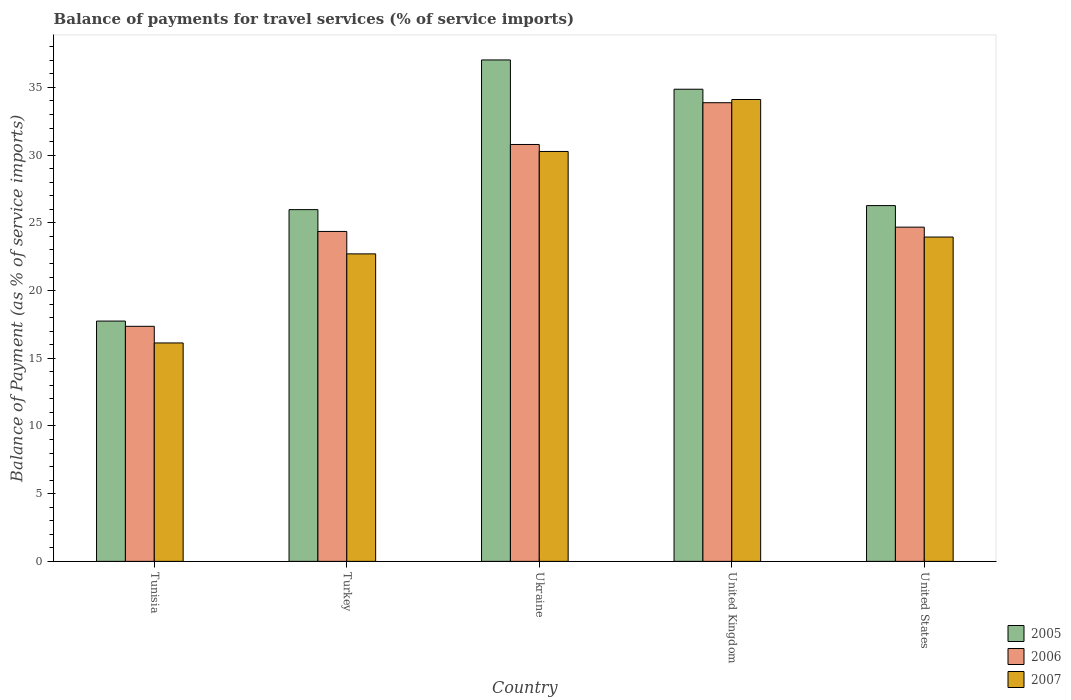How many different coloured bars are there?
Offer a terse response. 3. How many groups of bars are there?
Offer a very short reply. 5. How many bars are there on the 5th tick from the left?
Provide a short and direct response. 3. What is the balance of payments for travel services in 2006 in United States?
Give a very brief answer. 24.68. Across all countries, what is the maximum balance of payments for travel services in 2007?
Your response must be concise. 34.11. Across all countries, what is the minimum balance of payments for travel services in 2006?
Offer a very short reply. 17.36. In which country was the balance of payments for travel services in 2005 maximum?
Your answer should be very brief. Ukraine. In which country was the balance of payments for travel services in 2007 minimum?
Offer a terse response. Tunisia. What is the total balance of payments for travel services in 2005 in the graph?
Your response must be concise. 141.89. What is the difference between the balance of payments for travel services in 2007 in Turkey and that in United Kingdom?
Provide a succinct answer. -11.4. What is the difference between the balance of payments for travel services in 2007 in Ukraine and the balance of payments for travel services in 2005 in United Kingdom?
Offer a terse response. -4.6. What is the average balance of payments for travel services in 2005 per country?
Provide a short and direct response. 28.38. What is the difference between the balance of payments for travel services of/in 2007 and balance of payments for travel services of/in 2005 in United Kingdom?
Ensure brevity in your answer.  -0.76. In how many countries, is the balance of payments for travel services in 2005 greater than 19 %?
Your answer should be compact. 4. What is the ratio of the balance of payments for travel services in 2006 in Turkey to that in United Kingdom?
Your answer should be very brief. 0.72. What is the difference between the highest and the second highest balance of payments for travel services in 2006?
Provide a succinct answer. -9.19. What is the difference between the highest and the lowest balance of payments for travel services in 2007?
Your answer should be very brief. 17.98. In how many countries, is the balance of payments for travel services in 2005 greater than the average balance of payments for travel services in 2005 taken over all countries?
Give a very brief answer. 2. Is the sum of the balance of payments for travel services in 2005 in United Kingdom and United States greater than the maximum balance of payments for travel services in 2007 across all countries?
Offer a very short reply. Yes. What does the 2nd bar from the right in Turkey represents?
Give a very brief answer. 2006. How many bars are there?
Make the answer very short. 15. Are the values on the major ticks of Y-axis written in scientific E-notation?
Make the answer very short. No. Does the graph contain grids?
Keep it short and to the point. No. What is the title of the graph?
Ensure brevity in your answer.  Balance of payments for travel services (% of service imports). What is the label or title of the Y-axis?
Provide a succinct answer. Balance of Payment (as % of service imports). What is the Balance of Payment (as % of service imports) in 2005 in Tunisia?
Give a very brief answer. 17.75. What is the Balance of Payment (as % of service imports) of 2006 in Tunisia?
Ensure brevity in your answer.  17.36. What is the Balance of Payment (as % of service imports) of 2007 in Tunisia?
Keep it short and to the point. 16.13. What is the Balance of Payment (as % of service imports) of 2005 in Turkey?
Make the answer very short. 25.97. What is the Balance of Payment (as % of service imports) in 2006 in Turkey?
Your response must be concise. 24.36. What is the Balance of Payment (as % of service imports) of 2007 in Turkey?
Your answer should be very brief. 22.71. What is the Balance of Payment (as % of service imports) of 2005 in Ukraine?
Ensure brevity in your answer.  37.03. What is the Balance of Payment (as % of service imports) of 2006 in Ukraine?
Provide a short and direct response. 30.79. What is the Balance of Payment (as % of service imports) of 2007 in Ukraine?
Offer a very short reply. 30.27. What is the Balance of Payment (as % of service imports) in 2005 in United Kingdom?
Offer a very short reply. 34.87. What is the Balance of Payment (as % of service imports) of 2006 in United Kingdom?
Keep it short and to the point. 33.87. What is the Balance of Payment (as % of service imports) in 2007 in United Kingdom?
Make the answer very short. 34.11. What is the Balance of Payment (as % of service imports) of 2005 in United States?
Ensure brevity in your answer.  26.27. What is the Balance of Payment (as % of service imports) in 2006 in United States?
Provide a succinct answer. 24.68. What is the Balance of Payment (as % of service imports) of 2007 in United States?
Keep it short and to the point. 23.95. Across all countries, what is the maximum Balance of Payment (as % of service imports) in 2005?
Your response must be concise. 37.03. Across all countries, what is the maximum Balance of Payment (as % of service imports) in 2006?
Your answer should be very brief. 33.87. Across all countries, what is the maximum Balance of Payment (as % of service imports) in 2007?
Give a very brief answer. 34.11. Across all countries, what is the minimum Balance of Payment (as % of service imports) in 2005?
Your answer should be very brief. 17.75. Across all countries, what is the minimum Balance of Payment (as % of service imports) in 2006?
Offer a very short reply. 17.36. Across all countries, what is the minimum Balance of Payment (as % of service imports) of 2007?
Keep it short and to the point. 16.13. What is the total Balance of Payment (as % of service imports) in 2005 in the graph?
Your response must be concise. 141.89. What is the total Balance of Payment (as % of service imports) in 2006 in the graph?
Make the answer very short. 131.06. What is the total Balance of Payment (as % of service imports) of 2007 in the graph?
Make the answer very short. 127.17. What is the difference between the Balance of Payment (as % of service imports) of 2005 in Tunisia and that in Turkey?
Provide a succinct answer. -8.23. What is the difference between the Balance of Payment (as % of service imports) of 2006 in Tunisia and that in Turkey?
Provide a succinct answer. -7.01. What is the difference between the Balance of Payment (as % of service imports) in 2007 in Tunisia and that in Turkey?
Provide a succinct answer. -6.58. What is the difference between the Balance of Payment (as % of service imports) of 2005 in Tunisia and that in Ukraine?
Ensure brevity in your answer.  -19.28. What is the difference between the Balance of Payment (as % of service imports) of 2006 in Tunisia and that in Ukraine?
Offer a terse response. -13.43. What is the difference between the Balance of Payment (as % of service imports) of 2007 in Tunisia and that in Ukraine?
Offer a very short reply. -14.14. What is the difference between the Balance of Payment (as % of service imports) of 2005 in Tunisia and that in United Kingdom?
Ensure brevity in your answer.  -17.12. What is the difference between the Balance of Payment (as % of service imports) in 2006 in Tunisia and that in United Kingdom?
Provide a succinct answer. -16.51. What is the difference between the Balance of Payment (as % of service imports) in 2007 in Tunisia and that in United Kingdom?
Make the answer very short. -17.98. What is the difference between the Balance of Payment (as % of service imports) of 2005 in Tunisia and that in United States?
Your response must be concise. -8.53. What is the difference between the Balance of Payment (as % of service imports) in 2006 in Tunisia and that in United States?
Keep it short and to the point. -7.32. What is the difference between the Balance of Payment (as % of service imports) in 2007 in Tunisia and that in United States?
Your answer should be very brief. -7.82. What is the difference between the Balance of Payment (as % of service imports) in 2005 in Turkey and that in Ukraine?
Offer a terse response. -11.05. What is the difference between the Balance of Payment (as % of service imports) of 2006 in Turkey and that in Ukraine?
Keep it short and to the point. -6.42. What is the difference between the Balance of Payment (as % of service imports) in 2007 in Turkey and that in Ukraine?
Provide a succinct answer. -7.56. What is the difference between the Balance of Payment (as % of service imports) of 2005 in Turkey and that in United Kingdom?
Provide a short and direct response. -8.89. What is the difference between the Balance of Payment (as % of service imports) in 2006 in Turkey and that in United Kingdom?
Offer a terse response. -9.51. What is the difference between the Balance of Payment (as % of service imports) of 2007 in Turkey and that in United Kingdom?
Your answer should be compact. -11.4. What is the difference between the Balance of Payment (as % of service imports) in 2005 in Turkey and that in United States?
Offer a very short reply. -0.3. What is the difference between the Balance of Payment (as % of service imports) in 2006 in Turkey and that in United States?
Keep it short and to the point. -0.32. What is the difference between the Balance of Payment (as % of service imports) in 2007 in Turkey and that in United States?
Your answer should be very brief. -1.24. What is the difference between the Balance of Payment (as % of service imports) of 2005 in Ukraine and that in United Kingdom?
Provide a succinct answer. 2.16. What is the difference between the Balance of Payment (as % of service imports) of 2006 in Ukraine and that in United Kingdom?
Give a very brief answer. -3.08. What is the difference between the Balance of Payment (as % of service imports) of 2007 in Ukraine and that in United Kingdom?
Offer a terse response. -3.84. What is the difference between the Balance of Payment (as % of service imports) of 2005 in Ukraine and that in United States?
Offer a terse response. 10.76. What is the difference between the Balance of Payment (as % of service imports) of 2006 in Ukraine and that in United States?
Give a very brief answer. 6.11. What is the difference between the Balance of Payment (as % of service imports) in 2007 in Ukraine and that in United States?
Keep it short and to the point. 6.32. What is the difference between the Balance of Payment (as % of service imports) of 2005 in United Kingdom and that in United States?
Ensure brevity in your answer.  8.59. What is the difference between the Balance of Payment (as % of service imports) in 2006 in United Kingdom and that in United States?
Ensure brevity in your answer.  9.19. What is the difference between the Balance of Payment (as % of service imports) of 2007 in United Kingdom and that in United States?
Offer a very short reply. 10.16. What is the difference between the Balance of Payment (as % of service imports) of 2005 in Tunisia and the Balance of Payment (as % of service imports) of 2006 in Turkey?
Provide a short and direct response. -6.62. What is the difference between the Balance of Payment (as % of service imports) of 2005 in Tunisia and the Balance of Payment (as % of service imports) of 2007 in Turkey?
Your answer should be compact. -4.96. What is the difference between the Balance of Payment (as % of service imports) of 2006 in Tunisia and the Balance of Payment (as % of service imports) of 2007 in Turkey?
Offer a terse response. -5.35. What is the difference between the Balance of Payment (as % of service imports) in 2005 in Tunisia and the Balance of Payment (as % of service imports) in 2006 in Ukraine?
Your response must be concise. -13.04. What is the difference between the Balance of Payment (as % of service imports) in 2005 in Tunisia and the Balance of Payment (as % of service imports) in 2007 in Ukraine?
Keep it short and to the point. -12.53. What is the difference between the Balance of Payment (as % of service imports) in 2006 in Tunisia and the Balance of Payment (as % of service imports) in 2007 in Ukraine?
Your response must be concise. -12.91. What is the difference between the Balance of Payment (as % of service imports) of 2005 in Tunisia and the Balance of Payment (as % of service imports) of 2006 in United Kingdom?
Your response must be concise. -16.12. What is the difference between the Balance of Payment (as % of service imports) of 2005 in Tunisia and the Balance of Payment (as % of service imports) of 2007 in United Kingdom?
Provide a short and direct response. -16.36. What is the difference between the Balance of Payment (as % of service imports) in 2006 in Tunisia and the Balance of Payment (as % of service imports) in 2007 in United Kingdom?
Your answer should be compact. -16.75. What is the difference between the Balance of Payment (as % of service imports) of 2005 in Tunisia and the Balance of Payment (as % of service imports) of 2006 in United States?
Your response must be concise. -6.94. What is the difference between the Balance of Payment (as % of service imports) of 2005 in Tunisia and the Balance of Payment (as % of service imports) of 2007 in United States?
Provide a succinct answer. -6.2. What is the difference between the Balance of Payment (as % of service imports) in 2006 in Tunisia and the Balance of Payment (as % of service imports) in 2007 in United States?
Your response must be concise. -6.59. What is the difference between the Balance of Payment (as % of service imports) in 2005 in Turkey and the Balance of Payment (as % of service imports) in 2006 in Ukraine?
Offer a terse response. -4.81. What is the difference between the Balance of Payment (as % of service imports) in 2005 in Turkey and the Balance of Payment (as % of service imports) in 2007 in Ukraine?
Ensure brevity in your answer.  -4.3. What is the difference between the Balance of Payment (as % of service imports) in 2006 in Turkey and the Balance of Payment (as % of service imports) in 2007 in Ukraine?
Give a very brief answer. -5.91. What is the difference between the Balance of Payment (as % of service imports) in 2005 in Turkey and the Balance of Payment (as % of service imports) in 2006 in United Kingdom?
Make the answer very short. -7.9. What is the difference between the Balance of Payment (as % of service imports) of 2005 in Turkey and the Balance of Payment (as % of service imports) of 2007 in United Kingdom?
Your answer should be very brief. -8.13. What is the difference between the Balance of Payment (as % of service imports) in 2006 in Turkey and the Balance of Payment (as % of service imports) in 2007 in United Kingdom?
Your answer should be compact. -9.74. What is the difference between the Balance of Payment (as % of service imports) of 2005 in Turkey and the Balance of Payment (as % of service imports) of 2006 in United States?
Your answer should be very brief. 1.29. What is the difference between the Balance of Payment (as % of service imports) in 2005 in Turkey and the Balance of Payment (as % of service imports) in 2007 in United States?
Keep it short and to the point. 2.02. What is the difference between the Balance of Payment (as % of service imports) of 2006 in Turkey and the Balance of Payment (as % of service imports) of 2007 in United States?
Your response must be concise. 0.41. What is the difference between the Balance of Payment (as % of service imports) of 2005 in Ukraine and the Balance of Payment (as % of service imports) of 2006 in United Kingdom?
Make the answer very short. 3.16. What is the difference between the Balance of Payment (as % of service imports) in 2005 in Ukraine and the Balance of Payment (as % of service imports) in 2007 in United Kingdom?
Keep it short and to the point. 2.92. What is the difference between the Balance of Payment (as % of service imports) of 2006 in Ukraine and the Balance of Payment (as % of service imports) of 2007 in United Kingdom?
Keep it short and to the point. -3.32. What is the difference between the Balance of Payment (as % of service imports) of 2005 in Ukraine and the Balance of Payment (as % of service imports) of 2006 in United States?
Offer a terse response. 12.35. What is the difference between the Balance of Payment (as % of service imports) of 2005 in Ukraine and the Balance of Payment (as % of service imports) of 2007 in United States?
Provide a succinct answer. 13.08. What is the difference between the Balance of Payment (as % of service imports) in 2006 in Ukraine and the Balance of Payment (as % of service imports) in 2007 in United States?
Offer a very short reply. 6.84. What is the difference between the Balance of Payment (as % of service imports) in 2005 in United Kingdom and the Balance of Payment (as % of service imports) in 2006 in United States?
Provide a succinct answer. 10.19. What is the difference between the Balance of Payment (as % of service imports) in 2005 in United Kingdom and the Balance of Payment (as % of service imports) in 2007 in United States?
Your response must be concise. 10.92. What is the difference between the Balance of Payment (as % of service imports) in 2006 in United Kingdom and the Balance of Payment (as % of service imports) in 2007 in United States?
Your response must be concise. 9.92. What is the average Balance of Payment (as % of service imports) in 2005 per country?
Ensure brevity in your answer.  28.38. What is the average Balance of Payment (as % of service imports) of 2006 per country?
Your answer should be compact. 26.21. What is the average Balance of Payment (as % of service imports) in 2007 per country?
Your answer should be very brief. 25.43. What is the difference between the Balance of Payment (as % of service imports) of 2005 and Balance of Payment (as % of service imports) of 2006 in Tunisia?
Keep it short and to the point. 0.39. What is the difference between the Balance of Payment (as % of service imports) of 2005 and Balance of Payment (as % of service imports) of 2007 in Tunisia?
Your answer should be very brief. 1.62. What is the difference between the Balance of Payment (as % of service imports) of 2006 and Balance of Payment (as % of service imports) of 2007 in Tunisia?
Give a very brief answer. 1.23. What is the difference between the Balance of Payment (as % of service imports) of 2005 and Balance of Payment (as % of service imports) of 2006 in Turkey?
Give a very brief answer. 1.61. What is the difference between the Balance of Payment (as % of service imports) in 2005 and Balance of Payment (as % of service imports) in 2007 in Turkey?
Provide a succinct answer. 3.27. What is the difference between the Balance of Payment (as % of service imports) of 2006 and Balance of Payment (as % of service imports) of 2007 in Turkey?
Your answer should be compact. 1.66. What is the difference between the Balance of Payment (as % of service imports) of 2005 and Balance of Payment (as % of service imports) of 2006 in Ukraine?
Offer a terse response. 6.24. What is the difference between the Balance of Payment (as % of service imports) in 2005 and Balance of Payment (as % of service imports) in 2007 in Ukraine?
Provide a short and direct response. 6.76. What is the difference between the Balance of Payment (as % of service imports) in 2006 and Balance of Payment (as % of service imports) in 2007 in Ukraine?
Provide a succinct answer. 0.52. What is the difference between the Balance of Payment (as % of service imports) of 2005 and Balance of Payment (as % of service imports) of 2006 in United Kingdom?
Give a very brief answer. 1. What is the difference between the Balance of Payment (as % of service imports) of 2005 and Balance of Payment (as % of service imports) of 2007 in United Kingdom?
Make the answer very short. 0.76. What is the difference between the Balance of Payment (as % of service imports) of 2006 and Balance of Payment (as % of service imports) of 2007 in United Kingdom?
Ensure brevity in your answer.  -0.24. What is the difference between the Balance of Payment (as % of service imports) of 2005 and Balance of Payment (as % of service imports) of 2006 in United States?
Offer a very short reply. 1.59. What is the difference between the Balance of Payment (as % of service imports) in 2005 and Balance of Payment (as % of service imports) in 2007 in United States?
Provide a succinct answer. 2.32. What is the difference between the Balance of Payment (as % of service imports) of 2006 and Balance of Payment (as % of service imports) of 2007 in United States?
Ensure brevity in your answer.  0.73. What is the ratio of the Balance of Payment (as % of service imports) in 2005 in Tunisia to that in Turkey?
Your answer should be very brief. 0.68. What is the ratio of the Balance of Payment (as % of service imports) of 2006 in Tunisia to that in Turkey?
Keep it short and to the point. 0.71. What is the ratio of the Balance of Payment (as % of service imports) in 2007 in Tunisia to that in Turkey?
Provide a short and direct response. 0.71. What is the ratio of the Balance of Payment (as % of service imports) in 2005 in Tunisia to that in Ukraine?
Give a very brief answer. 0.48. What is the ratio of the Balance of Payment (as % of service imports) in 2006 in Tunisia to that in Ukraine?
Offer a very short reply. 0.56. What is the ratio of the Balance of Payment (as % of service imports) in 2007 in Tunisia to that in Ukraine?
Ensure brevity in your answer.  0.53. What is the ratio of the Balance of Payment (as % of service imports) of 2005 in Tunisia to that in United Kingdom?
Offer a very short reply. 0.51. What is the ratio of the Balance of Payment (as % of service imports) of 2006 in Tunisia to that in United Kingdom?
Your answer should be compact. 0.51. What is the ratio of the Balance of Payment (as % of service imports) in 2007 in Tunisia to that in United Kingdom?
Give a very brief answer. 0.47. What is the ratio of the Balance of Payment (as % of service imports) in 2005 in Tunisia to that in United States?
Give a very brief answer. 0.68. What is the ratio of the Balance of Payment (as % of service imports) of 2006 in Tunisia to that in United States?
Provide a succinct answer. 0.7. What is the ratio of the Balance of Payment (as % of service imports) in 2007 in Tunisia to that in United States?
Keep it short and to the point. 0.67. What is the ratio of the Balance of Payment (as % of service imports) of 2005 in Turkey to that in Ukraine?
Your answer should be very brief. 0.7. What is the ratio of the Balance of Payment (as % of service imports) of 2006 in Turkey to that in Ukraine?
Provide a succinct answer. 0.79. What is the ratio of the Balance of Payment (as % of service imports) of 2007 in Turkey to that in Ukraine?
Ensure brevity in your answer.  0.75. What is the ratio of the Balance of Payment (as % of service imports) in 2005 in Turkey to that in United Kingdom?
Provide a short and direct response. 0.74. What is the ratio of the Balance of Payment (as % of service imports) of 2006 in Turkey to that in United Kingdom?
Your answer should be compact. 0.72. What is the ratio of the Balance of Payment (as % of service imports) of 2007 in Turkey to that in United Kingdom?
Keep it short and to the point. 0.67. What is the ratio of the Balance of Payment (as % of service imports) in 2006 in Turkey to that in United States?
Ensure brevity in your answer.  0.99. What is the ratio of the Balance of Payment (as % of service imports) in 2007 in Turkey to that in United States?
Provide a short and direct response. 0.95. What is the ratio of the Balance of Payment (as % of service imports) in 2005 in Ukraine to that in United Kingdom?
Give a very brief answer. 1.06. What is the ratio of the Balance of Payment (as % of service imports) in 2006 in Ukraine to that in United Kingdom?
Give a very brief answer. 0.91. What is the ratio of the Balance of Payment (as % of service imports) in 2007 in Ukraine to that in United Kingdom?
Your answer should be compact. 0.89. What is the ratio of the Balance of Payment (as % of service imports) in 2005 in Ukraine to that in United States?
Give a very brief answer. 1.41. What is the ratio of the Balance of Payment (as % of service imports) of 2006 in Ukraine to that in United States?
Your answer should be very brief. 1.25. What is the ratio of the Balance of Payment (as % of service imports) in 2007 in Ukraine to that in United States?
Provide a short and direct response. 1.26. What is the ratio of the Balance of Payment (as % of service imports) of 2005 in United Kingdom to that in United States?
Offer a very short reply. 1.33. What is the ratio of the Balance of Payment (as % of service imports) in 2006 in United Kingdom to that in United States?
Your answer should be very brief. 1.37. What is the ratio of the Balance of Payment (as % of service imports) of 2007 in United Kingdom to that in United States?
Keep it short and to the point. 1.42. What is the difference between the highest and the second highest Balance of Payment (as % of service imports) of 2005?
Make the answer very short. 2.16. What is the difference between the highest and the second highest Balance of Payment (as % of service imports) of 2006?
Ensure brevity in your answer.  3.08. What is the difference between the highest and the second highest Balance of Payment (as % of service imports) of 2007?
Give a very brief answer. 3.84. What is the difference between the highest and the lowest Balance of Payment (as % of service imports) of 2005?
Offer a terse response. 19.28. What is the difference between the highest and the lowest Balance of Payment (as % of service imports) of 2006?
Ensure brevity in your answer.  16.51. What is the difference between the highest and the lowest Balance of Payment (as % of service imports) in 2007?
Your response must be concise. 17.98. 